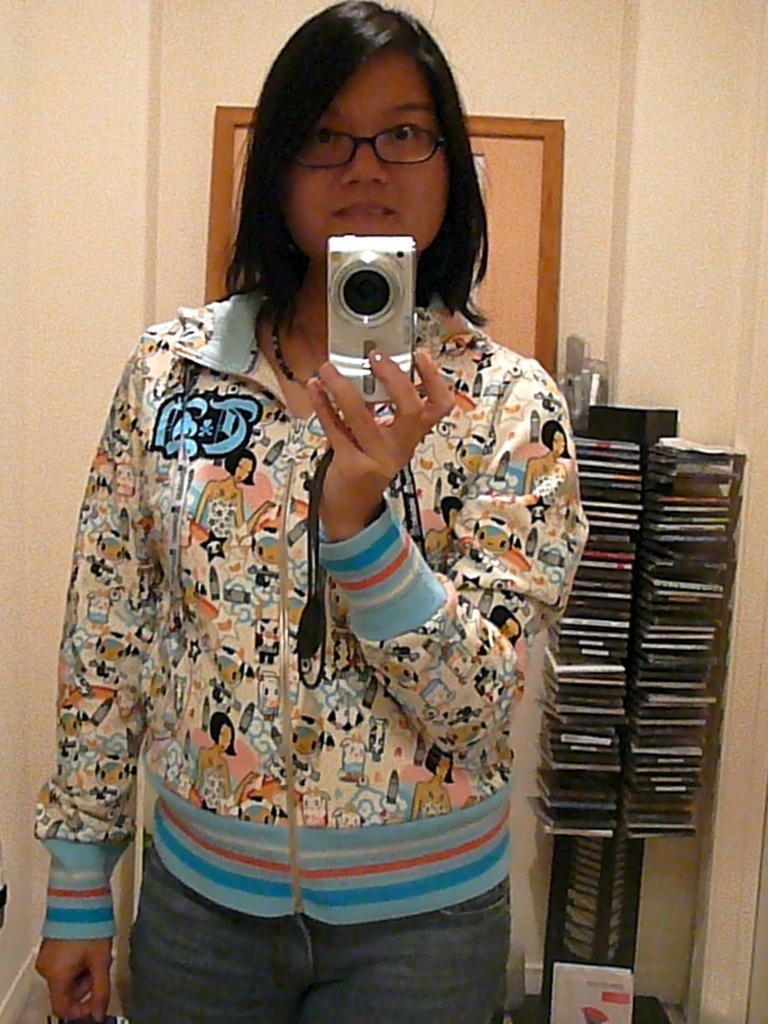Who is the main subject in the image? There is a lady in the image. What is the lady wearing? The lady is wearing a jacket with blue, red, and white colors. What is the lady holding in the image? The lady is holding a camera. What is the lady doing with the camera? The lady is taking a picture in front of a mirror. What can be seen behind the lady? There are books visible behind the lady. What other object is present in the image? There is a frame in the image. What type of toy can be seen in the lady's hand in the image? There is no toy present in the lady's hand in the image; she is holding a camera. How much salt is visible on the mirror in the image? There is no salt visible on the mirror in the image. 